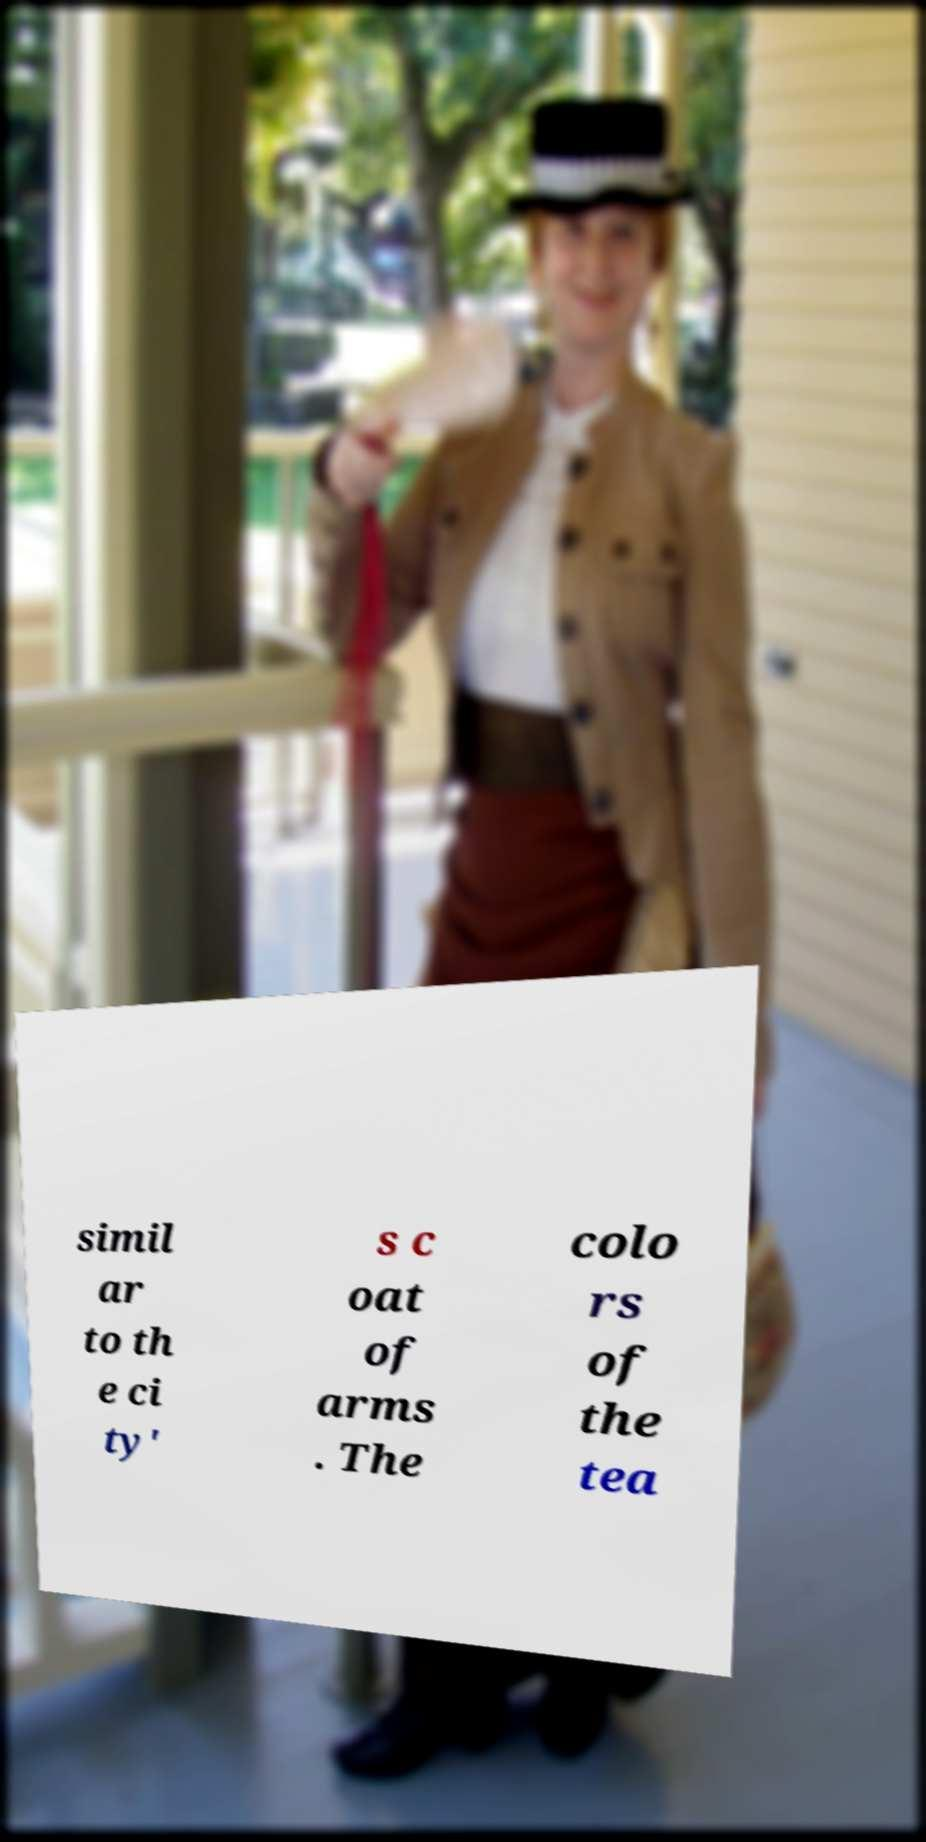I need the written content from this picture converted into text. Can you do that? simil ar to th e ci ty' s c oat of arms . The colo rs of the tea 